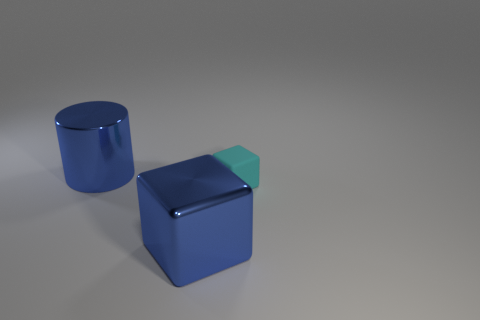What is the color of the cube that is in front of the small cube?
Your answer should be compact. Blue. Does the metallic object that is on the right side of the cylinder have the same size as the thing that is behind the small object?
Make the answer very short. Yes. Is there a shiny object that has the same size as the cyan matte object?
Keep it short and to the point. No. There is a cube on the right side of the large blue block; what number of large cylinders are on the left side of it?
Provide a short and direct response. 1. What is the material of the blue cube?
Give a very brief answer. Metal. How many blue things are in front of the matte object?
Your answer should be very brief. 1. Is the color of the big metal cube the same as the small block?
Offer a terse response. No. What number of objects are the same color as the large shiny cube?
Offer a terse response. 1. Is the number of small cyan matte cylinders greater than the number of rubber cubes?
Make the answer very short. No. What is the size of the object that is behind the big cube and right of the big blue cylinder?
Your answer should be compact. Small. 